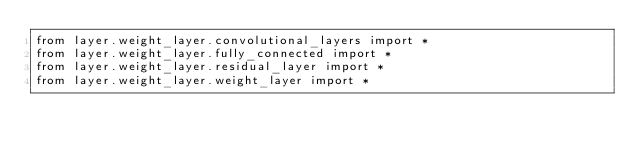<code> <loc_0><loc_0><loc_500><loc_500><_Python_>from layer.weight_layer.convolutional_layers import *
from layer.weight_layer.fully_connected import *
from layer.weight_layer.residual_layer import *
from layer.weight_layer.weight_layer import *</code> 